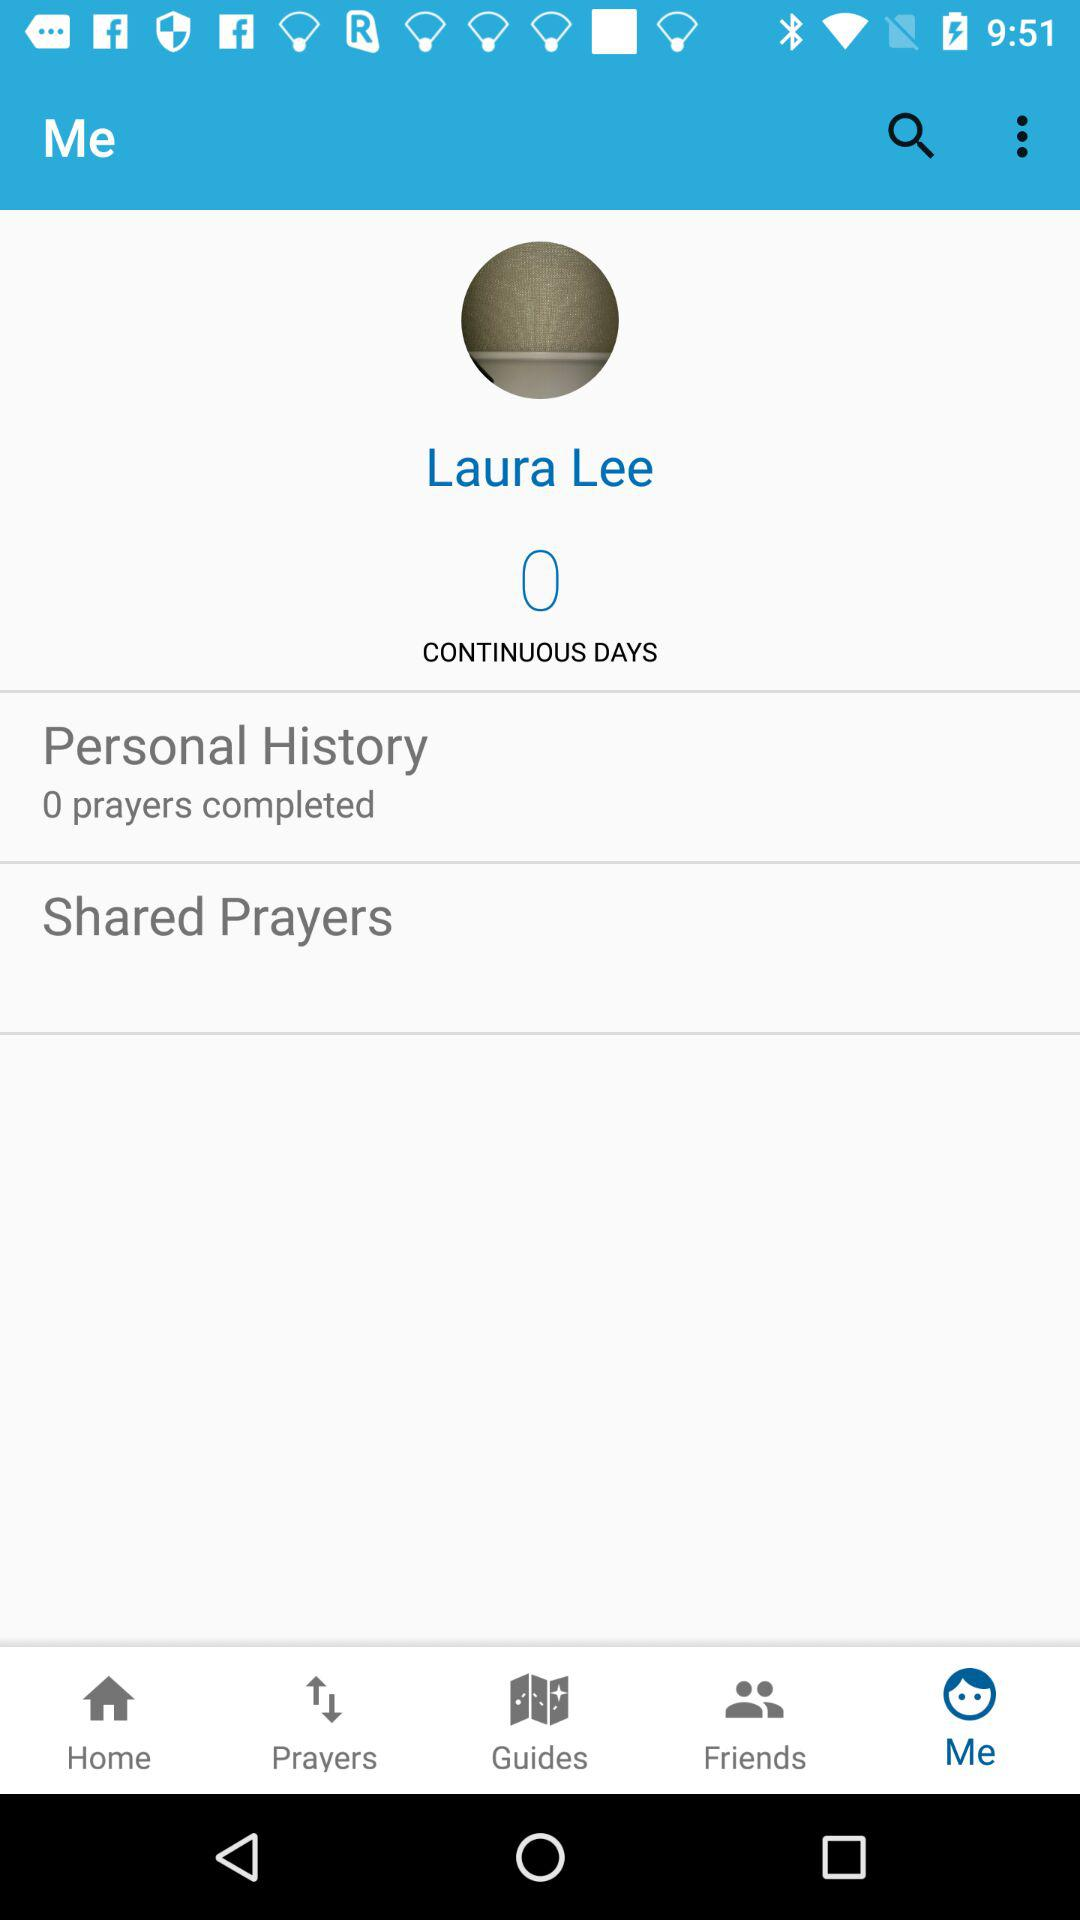How many prayers does Laura Lee have completed?
Answer the question using a single word or phrase. 0 